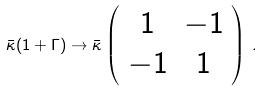Convert formula to latex. <formula><loc_0><loc_0><loc_500><loc_500>\bar { \kappa } ( 1 + \Gamma ) \to \bar { \kappa } \left ( \begin{array} { c c } { 1 } & { - 1 } \\ { - 1 } & { 1 } \end{array} \right ) \, .</formula> 